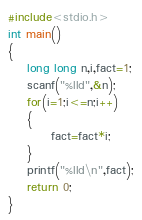Convert code to text. <code><loc_0><loc_0><loc_500><loc_500><_C_>
#include<stdio.h>
int main()
{
    long long n,i,fact=1;
    scanf("%lld",&n);
    for(i=1;i<=n;i++)
    {
         fact=fact*i;
    }
    printf("%lld\n",fact);
    return 0;
}</code> 